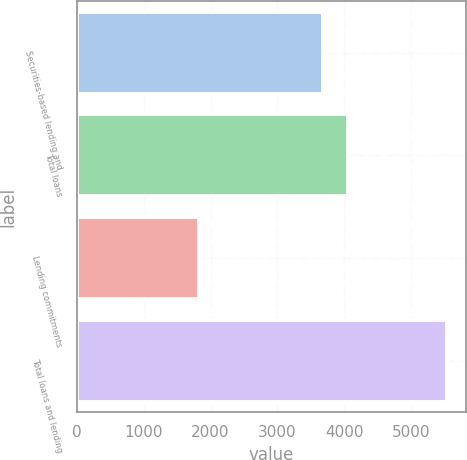Convert chart. <chart><loc_0><loc_0><loc_500><loc_500><bar_chart><fcel>Securities-based lending and<fcel>Total loans<fcel>Lending commitments<fcel>Total loans and lending<nl><fcel>3687<fcel>4058.1<fcel>1827<fcel>5538<nl></chart> 